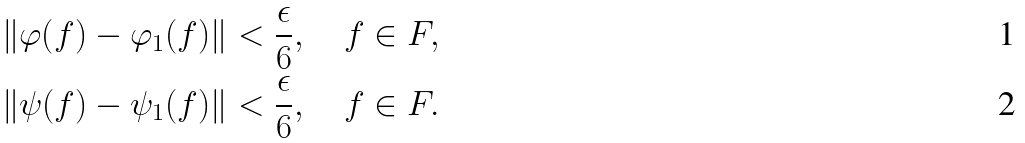Convert formula to latex. <formula><loc_0><loc_0><loc_500><loc_500>\| \varphi ( f ) - \varphi _ { 1 } ( f ) \| < \frac { \epsilon } 6 , \quad f \in F , \\ \| \psi ( f ) - \psi _ { 1 } ( f ) \| < \frac { \epsilon } 6 , \quad f \in F .</formula> 